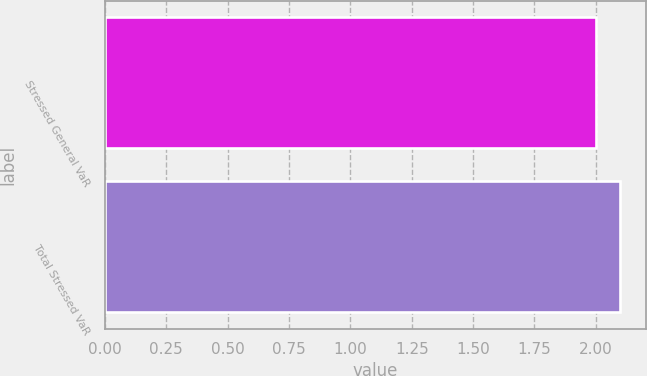<chart> <loc_0><loc_0><loc_500><loc_500><bar_chart><fcel>Stressed General VaR<fcel>Total Stressed VaR<nl><fcel>2<fcel>2.1<nl></chart> 